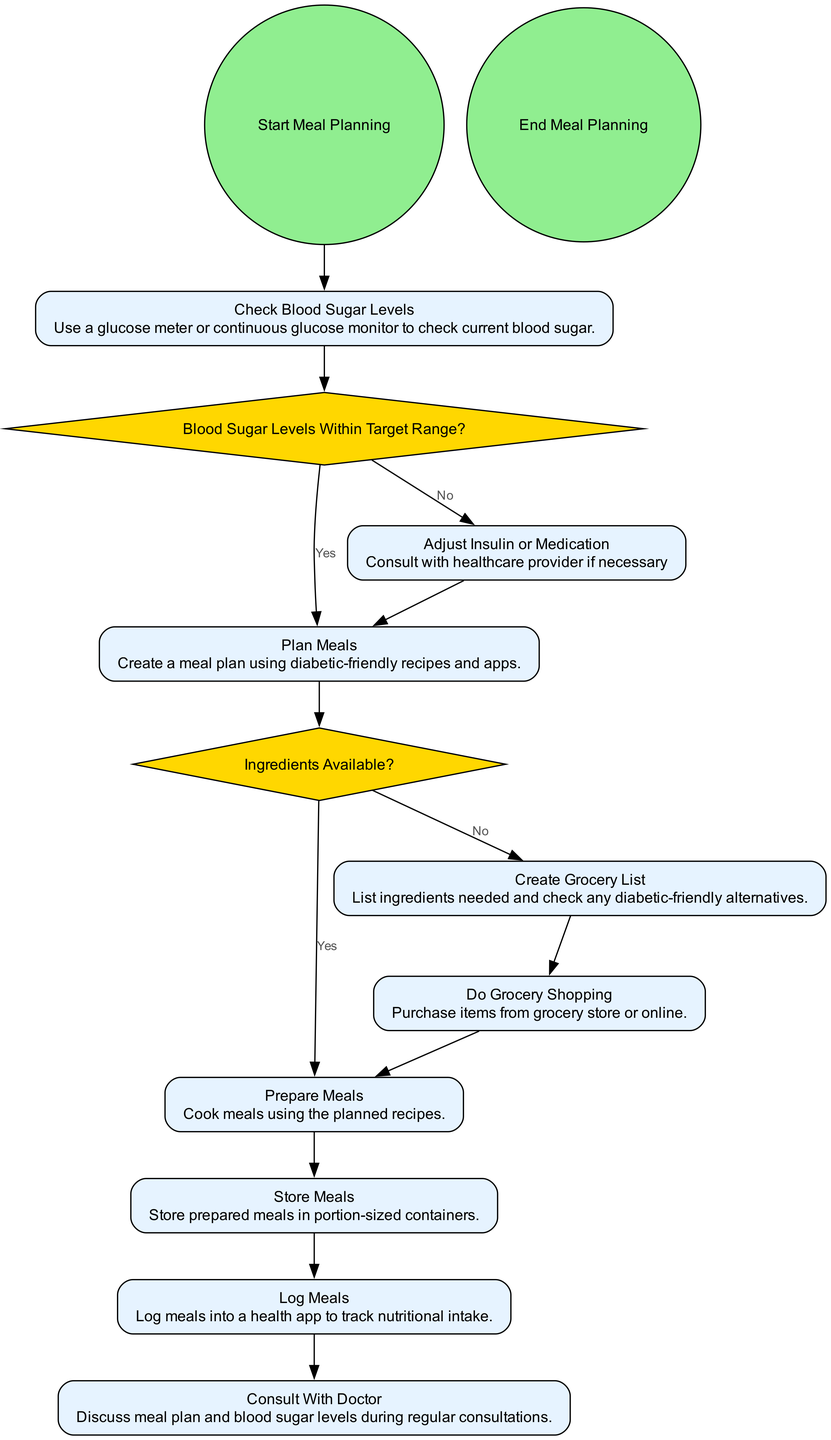What is the first step in the meal planning process? The diagram starts with the "Start Meal Planning" event, indicating it is the first step in the process.
Answer: Start Meal Planning How many decision points are present in the diagram? The diagram contains two decision points: "Blood Sugar Levels Within Target Range?" and "Ingredients Available?" Therefore, the count is 2.
Answer: 2 What happens if blood sugar levels are not within the target range? If the blood sugar levels are not within the target range, the flow leads to the action "Adjust Insulin or Medication" as indicated in the decision section.
Answer: Adjust Insulin or Medication What is the final action performed before ending the meal planning process? The last action before reaching the "End Meal Planning" is "Log Meals," which is performed to track nutritional intake.
Answer: Log Meals How do you proceed if ingredients are not available? If ingredients are not available, the next action to be taken is "Create Grocery List," as depicted in the decision "Ingredients Available?"
Answer: Create Grocery List What action must be taken after meal planning is complete? After the meal planning is complete, the final action is to "Consult With Doctor," where the meal plan and blood sugar levels are discussed.
Answer: Consult With Doctor Which action involves shopping for groceries? The action that involves shopping for groceries is "Do Grocery Shopping," which comes after creating a grocery list if ingredients are not available.
Answer: Do Grocery Shopping What conditional flow dictates whether to adjust insulin or proceed with meal planning? The conditional flow from the decision "Blood Sugar Levels Within Target Range?" dictates that if the answer is "No," you should "Adjust Insulin or Medication."
Answer: Adjust Insulin or Medication 